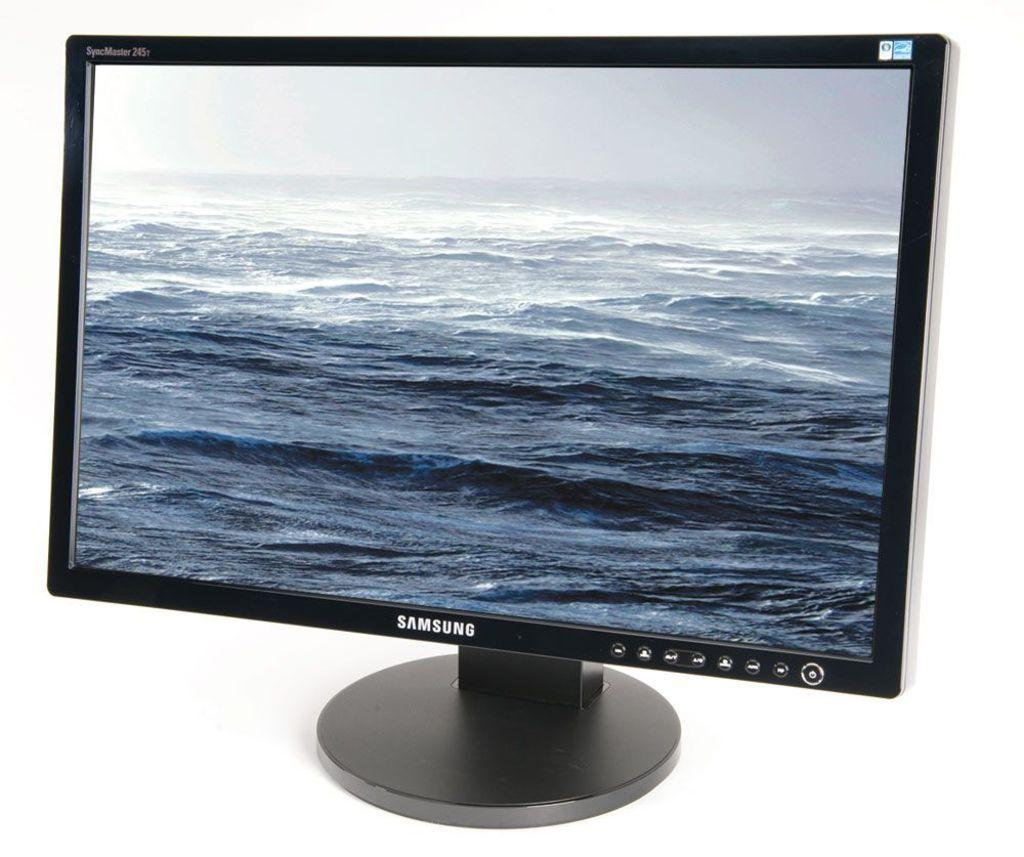Provide a one-sentence caption for the provided image. A Samsung computer monitor against a white backdrop. 